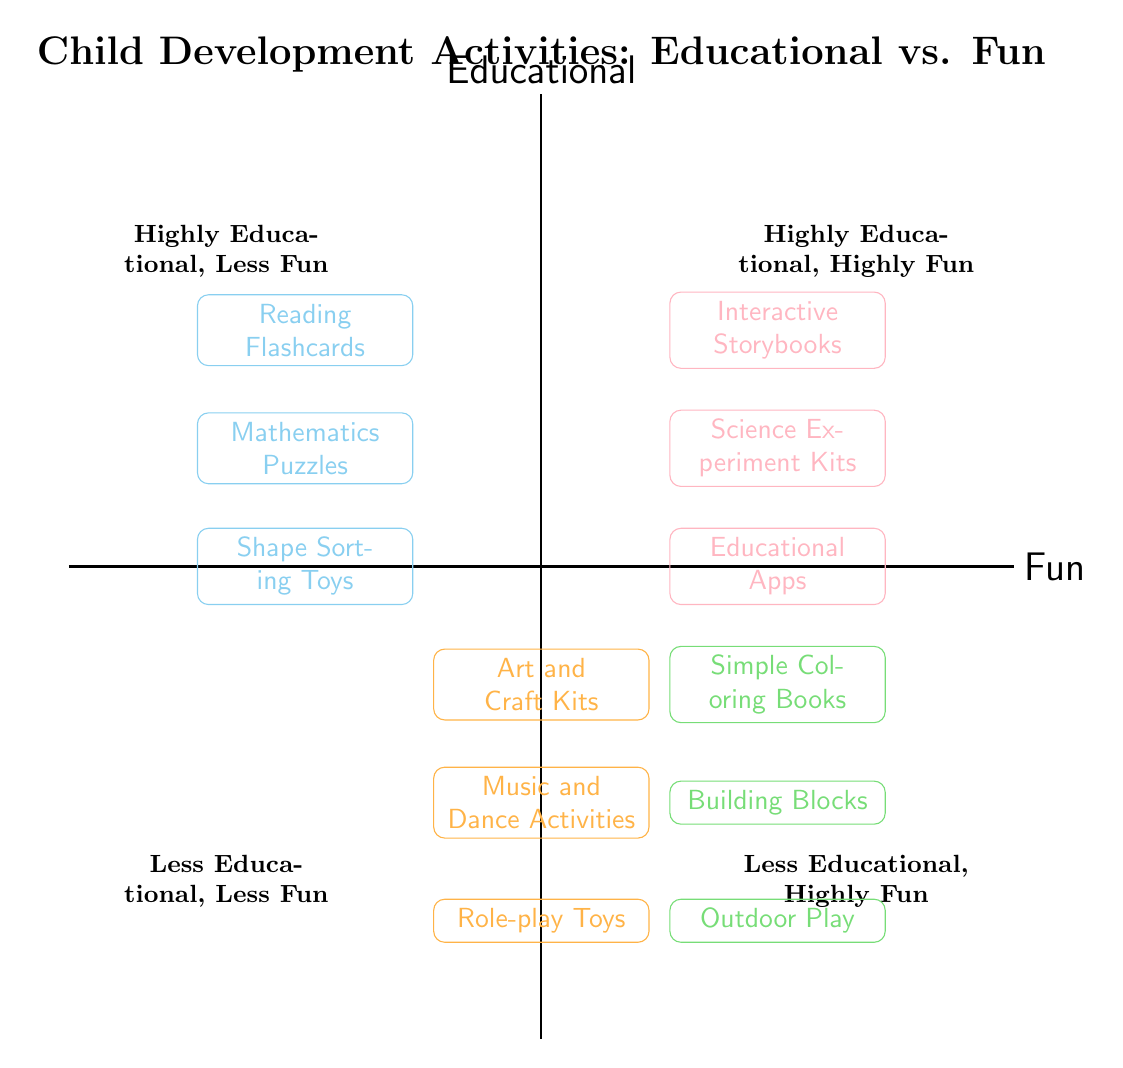What activities are found in the "Highly Educational, Less Fun" quadrant? The question asks for specific activities that are categorized in the quadrant titled "Highly Educational, Less Fun". By reviewing the diagram, this data can be found, and I can list them as they are located there.
Answer: Reading Flashcards, Mathematics Puzzles, Shape Sorting Toys How many activities are categorized as "Highly Educational, Highly Fun"? This question focuses on counting the number of activities in the "Highly Educational, Highly Fun" quadrant. By looking at the diagram, we simply note the three listed activities.
Answer: 3 Which group includes "Music and Dance Activities"? The question is asking where the activity "Music and Dance Activities" is located within the quadrants. Upon reviewing, it falls under the "Moderately Educational, Highly Fun" section.
Answer: Moderately Educational, Highly Fun What type of activities are in the "Less Educational, Highly Fun" quadrant? This question prompts for the activities that are categorized under "Less Educational, Highly Fun". By inspecting that quadrant in the diagram, I can find and list the corresponding activities.
Answer: Simple Coloring Books, Building Blocks, Outdoor Play Identify how many activities are in the "Highly Educational" section overall. To answer this, I need to evaluate both quadrants that fall under the "Highly Educational" classification—both "Highly Educational, Less Fun" and "Highly Educational, Highly Fun" and sum up the activities from each.
Answer: 6 Which quadrant contains the most fun activities? This question requires me to identify which quadrant has activities that are primarily fun based on the labels. By reviewing the "Fun" classifications, I can determine that this is the "Less Educational, Highly Fun" quadrant.
Answer: Less Educational, Highly Fun Are there more activities that are fun or educational? Here, I must assess the total number of activities categorized under "Fun" versus those under "Educational". By counting them from the diagram, I conclude that there are more activities in the "Fun" category.
Answer: Fun How many types of activities are in the "Highly Educational, Highly Fun" quadrant? This question asks for a count of types of activities listed in the specific quadrant mentioned. By checking the diagram, I identify three activities here.
Answer: 3 